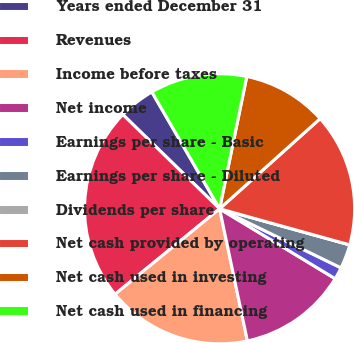<chart> <loc_0><loc_0><loc_500><loc_500><pie_chart><fcel>Years ended December 31<fcel>Revenues<fcel>Income before taxes<fcel>Net income<fcel>Earnings per share - Basic<fcel>Earnings per share - Diluted<fcel>Dividends per share<fcel>Net cash provided by operating<fcel>Net cash used in investing<fcel>Net cash used in financing<nl><fcel>4.35%<fcel>23.19%<fcel>17.39%<fcel>13.04%<fcel>1.45%<fcel>2.9%<fcel>0.0%<fcel>15.94%<fcel>10.14%<fcel>11.59%<nl></chart> 